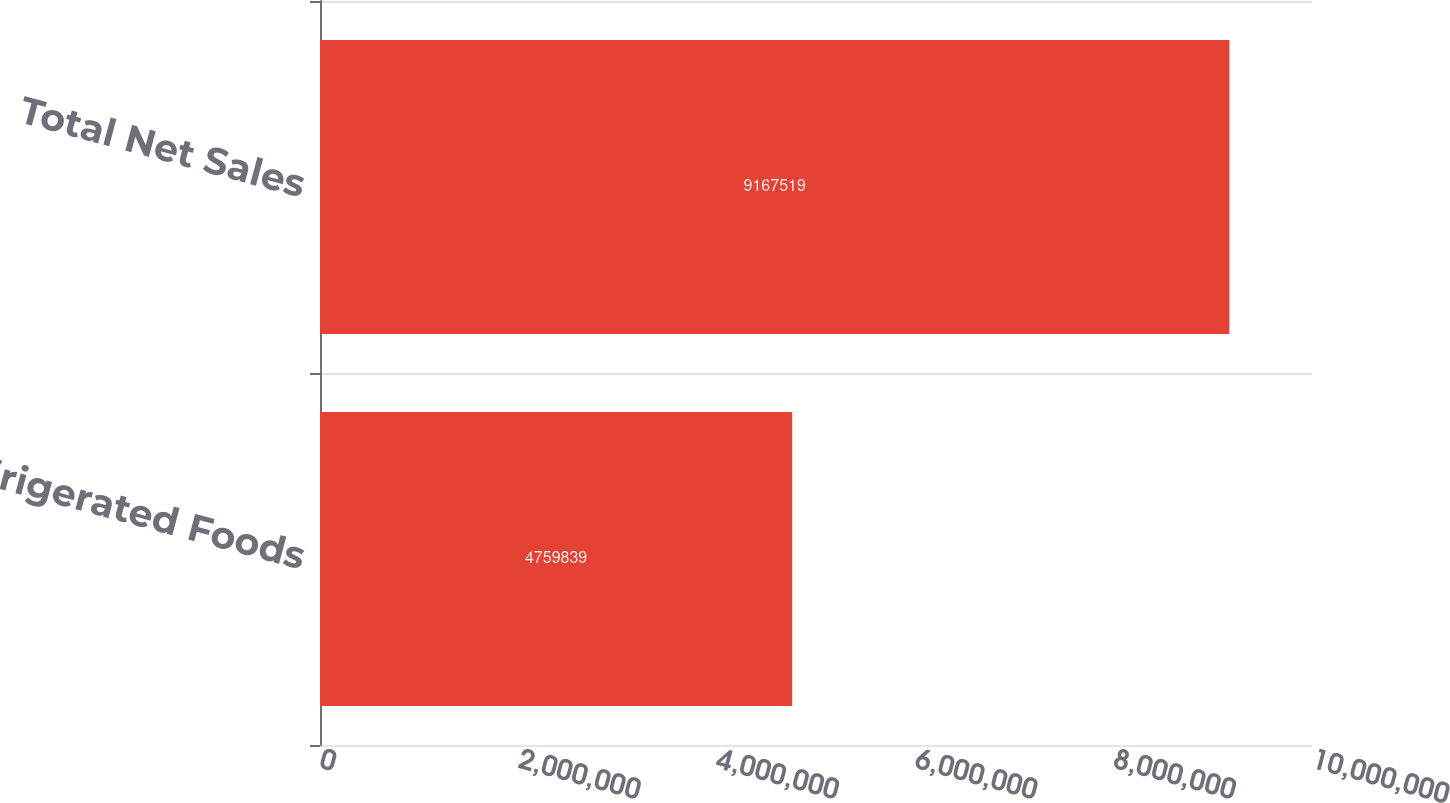<chart> <loc_0><loc_0><loc_500><loc_500><bar_chart><fcel>Refrigerated Foods<fcel>Total Net Sales<nl><fcel>4.75984e+06<fcel>9.16752e+06<nl></chart> 